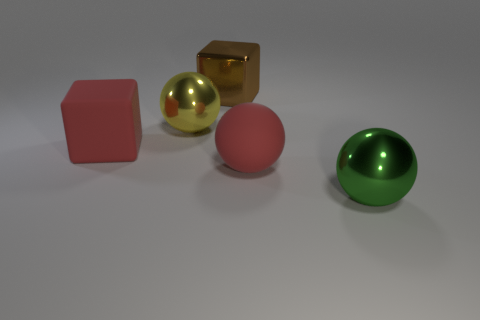Subtract all big shiny spheres. How many spheres are left? 1 Add 5 big shiny cubes. How many objects exist? 10 Subtract all green balls. How many balls are left? 2 Subtract all red balls. Subtract all yellow blocks. How many balls are left? 2 Subtract all yellow cubes. How many red spheres are left? 1 Subtract all brown metallic cylinders. Subtract all large matte spheres. How many objects are left? 4 Add 2 large matte things. How many large matte things are left? 4 Add 5 brown things. How many brown things exist? 6 Subtract 0 cyan balls. How many objects are left? 5 Subtract all cubes. How many objects are left? 3 